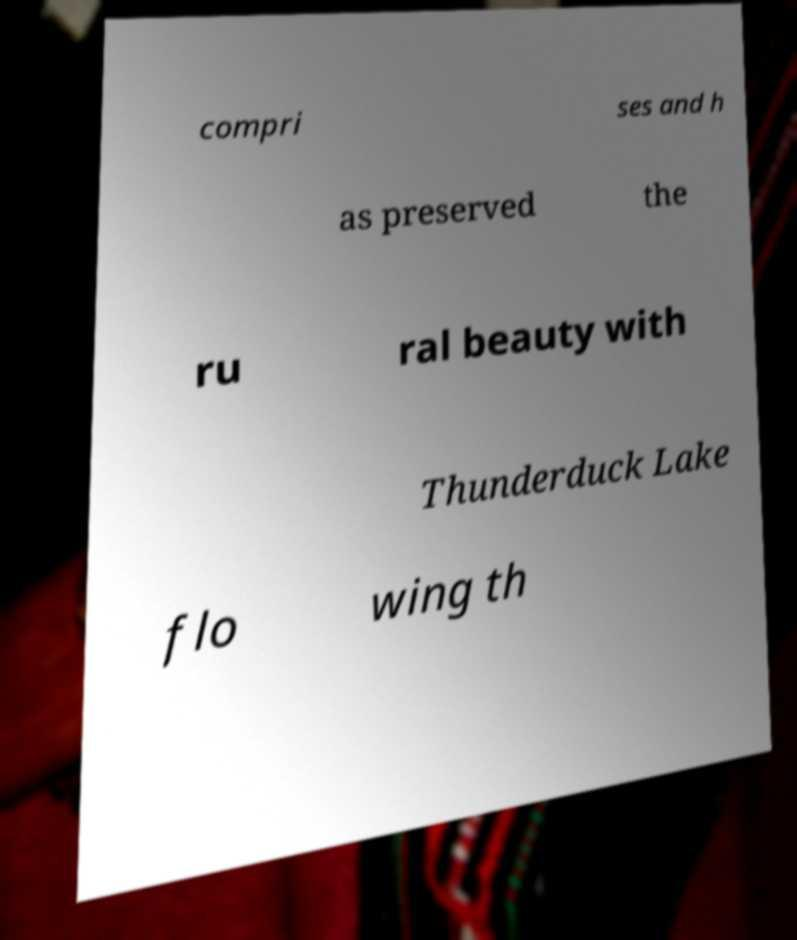For documentation purposes, I need the text within this image transcribed. Could you provide that? compri ses and h as preserved the ru ral beauty with Thunderduck Lake flo wing th 